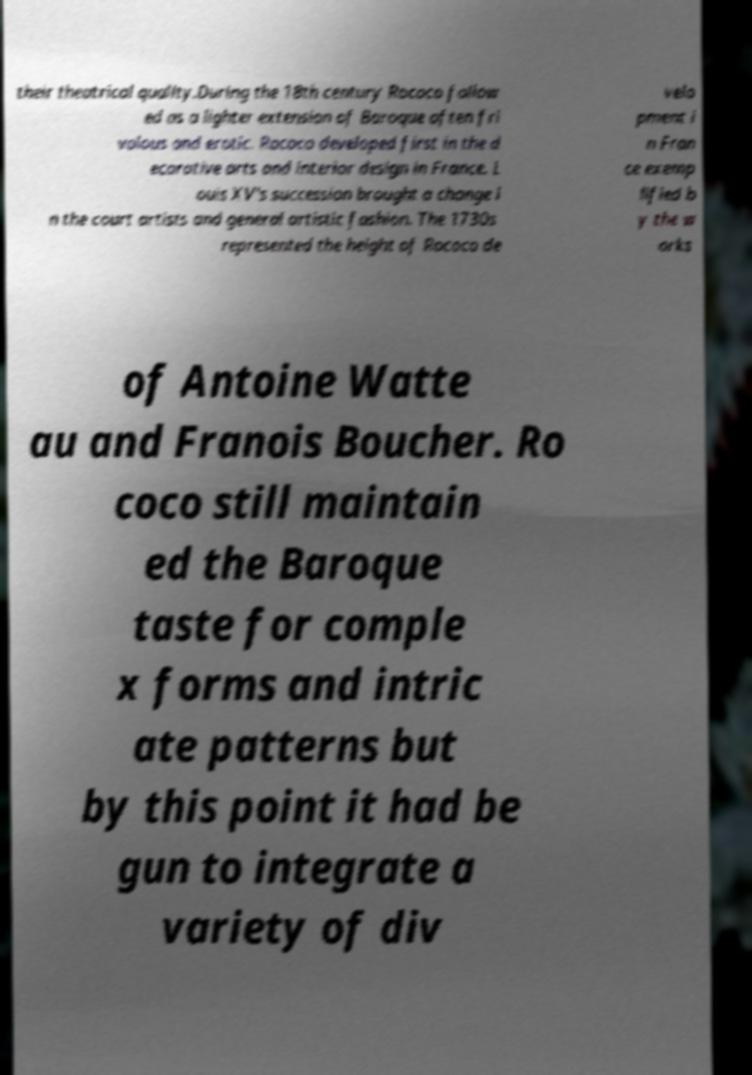Could you assist in decoding the text presented in this image and type it out clearly? their theatrical quality.During the 18th century Rococo follow ed as a lighter extension of Baroque often fri volous and erotic. Rococo developed first in the d ecorative arts and interior design in France. L ouis XV's succession brought a change i n the court artists and general artistic fashion. The 1730s represented the height of Rococo de velo pment i n Fran ce exemp lified b y the w orks of Antoine Watte au and Franois Boucher. Ro coco still maintain ed the Baroque taste for comple x forms and intric ate patterns but by this point it had be gun to integrate a variety of div 